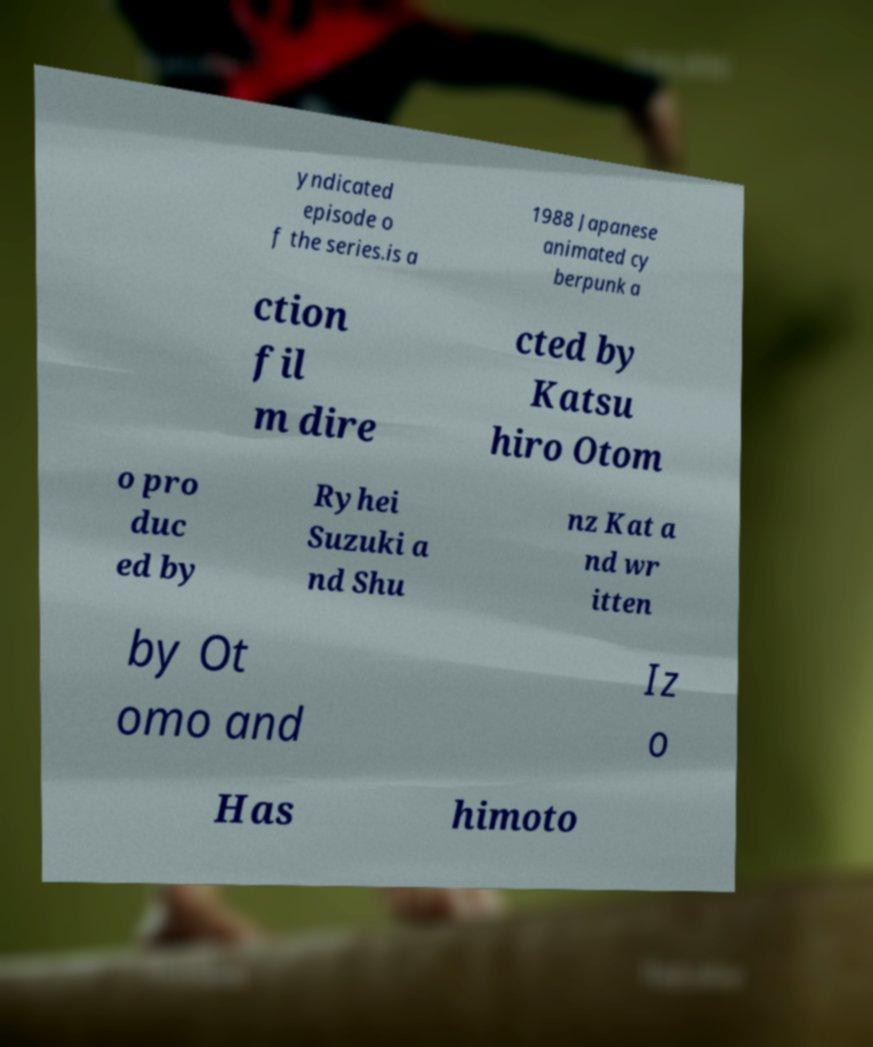Can you accurately transcribe the text from the provided image for me? yndicated episode o f the series.is a 1988 Japanese animated cy berpunk a ction fil m dire cted by Katsu hiro Otom o pro duc ed by Ryhei Suzuki a nd Shu nz Kat a nd wr itten by Ot omo and Iz o Has himoto 